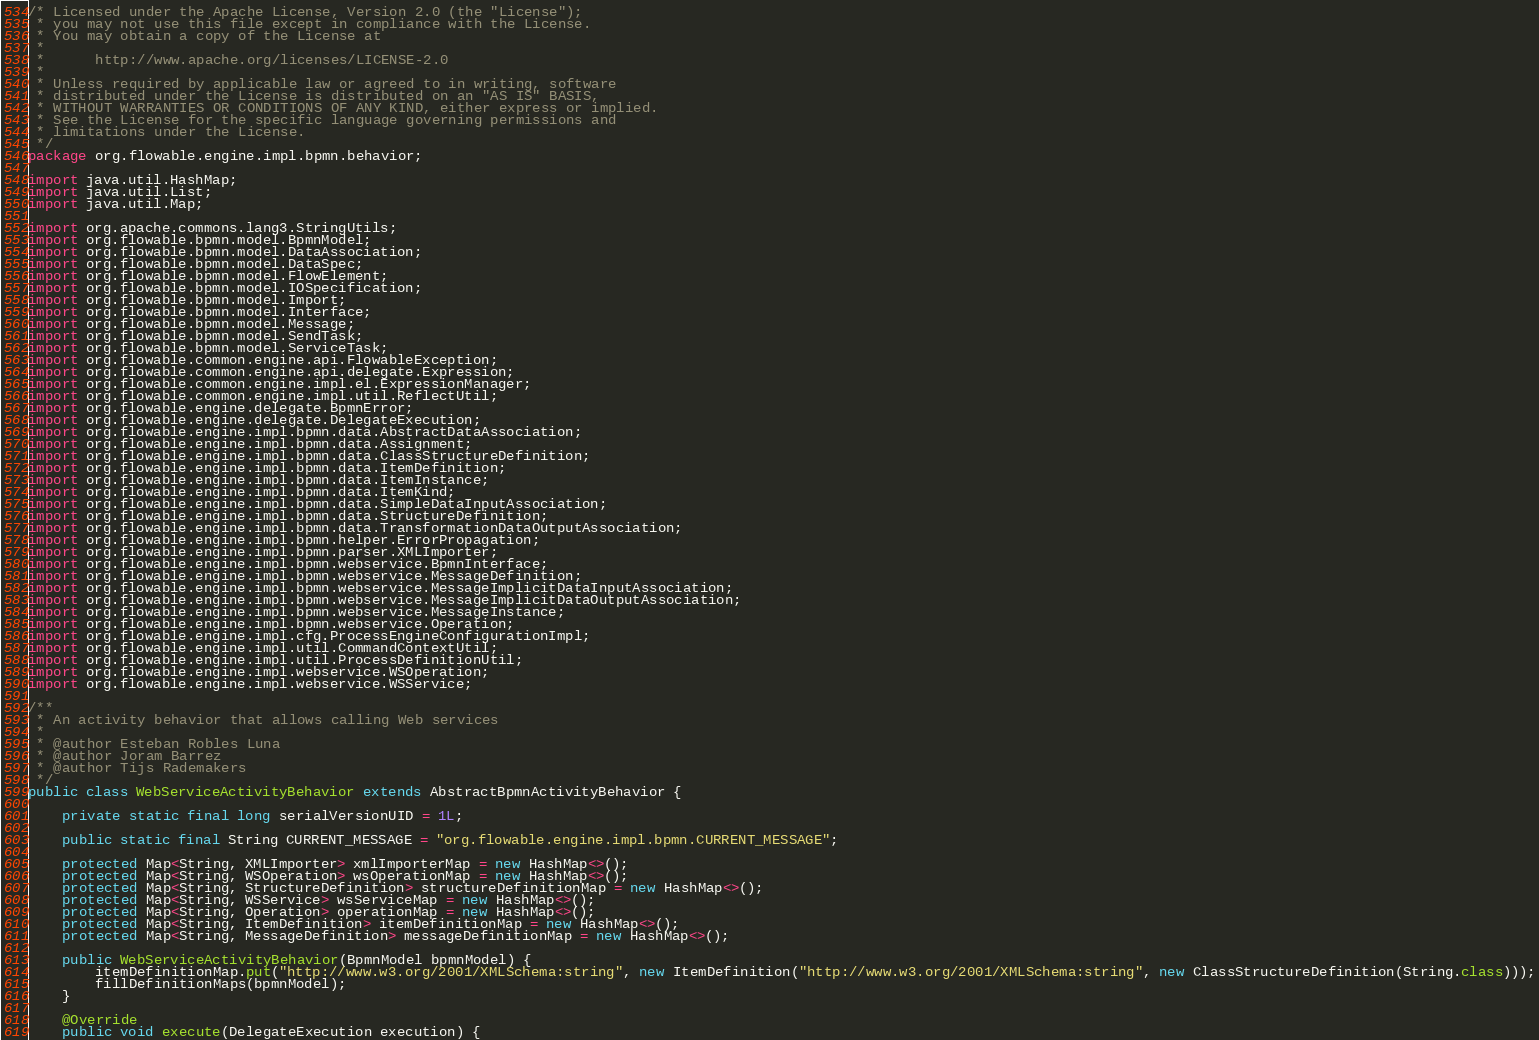Convert code to text. <code><loc_0><loc_0><loc_500><loc_500><_Java_>/* Licensed under the Apache License, Version 2.0 (the "License");
 * you may not use this file except in compliance with the License.
 * You may obtain a copy of the License at
 * 
 *      http://www.apache.org/licenses/LICENSE-2.0
 * 
 * Unless required by applicable law or agreed to in writing, software
 * distributed under the License is distributed on an "AS IS" BASIS,
 * WITHOUT WARRANTIES OR CONDITIONS OF ANY KIND, either express or implied.
 * See the License for the specific language governing permissions and
 * limitations under the License.
 */
package org.flowable.engine.impl.bpmn.behavior;

import java.util.HashMap;
import java.util.List;
import java.util.Map;

import org.apache.commons.lang3.StringUtils;
import org.flowable.bpmn.model.BpmnModel;
import org.flowable.bpmn.model.DataAssociation;
import org.flowable.bpmn.model.DataSpec;
import org.flowable.bpmn.model.FlowElement;
import org.flowable.bpmn.model.IOSpecification;
import org.flowable.bpmn.model.Import;
import org.flowable.bpmn.model.Interface;
import org.flowable.bpmn.model.Message;
import org.flowable.bpmn.model.SendTask;
import org.flowable.bpmn.model.ServiceTask;
import org.flowable.common.engine.api.FlowableException;
import org.flowable.common.engine.api.delegate.Expression;
import org.flowable.common.engine.impl.el.ExpressionManager;
import org.flowable.common.engine.impl.util.ReflectUtil;
import org.flowable.engine.delegate.BpmnError;
import org.flowable.engine.delegate.DelegateExecution;
import org.flowable.engine.impl.bpmn.data.AbstractDataAssociation;
import org.flowable.engine.impl.bpmn.data.Assignment;
import org.flowable.engine.impl.bpmn.data.ClassStructureDefinition;
import org.flowable.engine.impl.bpmn.data.ItemDefinition;
import org.flowable.engine.impl.bpmn.data.ItemInstance;
import org.flowable.engine.impl.bpmn.data.ItemKind;
import org.flowable.engine.impl.bpmn.data.SimpleDataInputAssociation;
import org.flowable.engine.impl.bpmn.data.StructureDefinition;
import org.flowable.engine.impl.bpmn.data.TransformationDataOutputAssociation;
import org.flowable.engine.impl.bpmn.helper.ErrorPropagation;
import org.flowable.engine.impl.bpmn.parser.XMLImporter;
import org.flowable.engine.impl.bpmn.webservice.BpmnInterface;
import org.flowable.engine.impl.bpmn.webservice.MessageDefinition;
import org.flowable.engine.impl.bpmn.webservice.MessageImplicitDataInputAssociation;
import org.flowable.engine.impl.bpmn.webservice.MessageImplicitDataOutputAssociation;
import org.flowable.engine.impl.bpmn.webservice.MessageInstance;
import org.flowable.engine.impl.bpmn.webservice.Operation;
import org.flowable.engine.impl.cfg.ProcessEngineConfigurationImpl;
import org.flowable.engine.impl.util.CommandContextUtil;
import org.flowable.engine.impl.util.ProcessDefinitionUtil;
import org.flowable.engine.impl.webservice.WSOperation;
import org.flowable.engine.impl.webservice.WSService;

/**
 * An activity behavior that allows calling Web services
 * 
 * @author Esteban Robles Luna
 * @author Joram Barrez
 * @author Tijs Rademakers
 */
public class WebServiceActivityBehavior extends AbstractBpmnActivityBehavior {

    private static final long serialVersionUID = 1L;

    public static final String CURRENT_MESSAGE = "org.flowable.engine.impl.bpmn.CURRENT_MESSAGE";

    protected Map<String, XMLImporter> xmlImporterMap = new HashMap<>();
    protected Map<String, WSOperation> wsOperationMap = new HashMap<>();
    protected Map<String, StructureDefinition> structureDefinitionMap = new HashMap<>();
    protected Map<String, WSService> wsServiceMap = new HashMap<>();
    protected Map<String, Operation> operationMap = new HashMap<>();
    protected Map<String, ItemDefinition> itemDefinitionMap = new HashMap<>();
    protected Map<String, MessageDefinition> messageDefinitionMap = new HashMap<>();

    public WebServiceActivityBehavior(BpmnModel bpmnModel) {
        itemDefinitionMap.put("http://www.w3.org/2001/XMLSchema:string", new ItemDefinition("http://www.w3.org/2001/XMLSchema:string", new ClassStructureDefinition(String.class)));
        fillDefinitionMaps(bpmnModel);
    }

    @Override
    public void execute(DelegateExecution execution) {</code> 